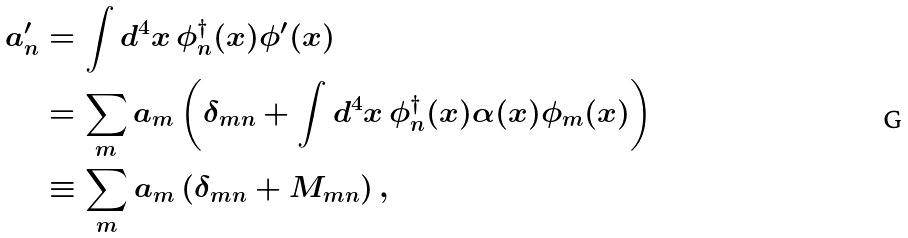<formula> <loc_0><loc_0><loc_500><loc_500>a ^ { \prime } _ { n } & = \int d ^ { 4 } x \, \phi ^ { \dagger } _ { n } ( x ) \phi ^ { \prime } ( x ) \\ & = \sum _ { m } a _ { m } \left ( \delta _ { m n } + \int d ^ { 4 } x \, \phi ^ { \dagger } _ { n } ( x ) \alpha ( x ) \phi _ { m } ( x ) \right ) \\ & \equiv \sum _ { m } a _ { m } \left ( \delta _ { m n } + M _ { m n } \right ) ,</formula> 